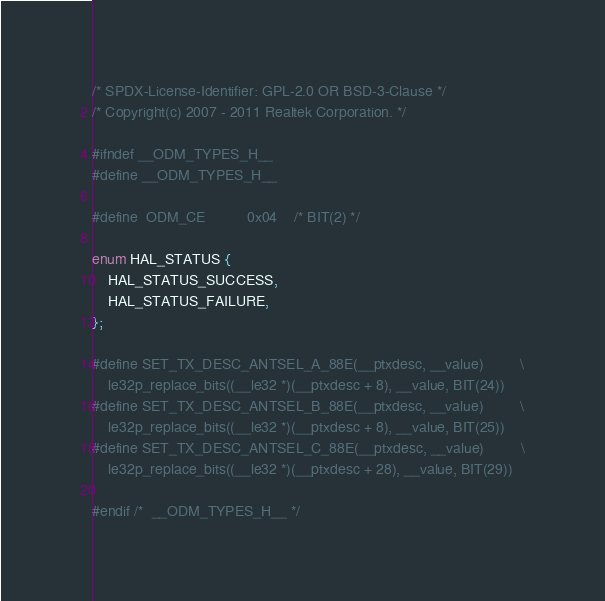<code> <loc_0><loc_0><loc_500><loc_500><_C_>/* SPDX-License-Identifier: GPL-2.0 OR BSD-3-Clause */
/* Copyright(c) 2007 - 2011 Realtek Corporation. */

#ifndef __ODM_TYPES_H__
#define __ODM_TYPES_H__

#define	ODM_CE			0x04	/* BIT(2) */

enum HAL_STATUS {
	HAL_STATUS_SUCCESS,
	HAL_STATUS_FAILURE,
};

#define SET_TX_DESC_ANTSEL_A_88E(__ptxdesc, __value)			\
	le32p_replace_bits((__le32 *)(__ptxdesc + 8), __value, BIT(24))
#define SET_TX_DESC_ANTSEL_B_88E(__ptxdesc, __value)			\
	le32p_replace_bits((__le32 *)(__ptxdesc + 8), __value, BIT(25))
#define SET_TX_DESC_ANTSEL_C_88E(__ptxdesc, __value)			\
	le32p_replace_bits((__le32 *)(__ptxdesc + 28), __value, BIT(29))

#endif /*  __ODM_TYPES_H__ */
</code> 